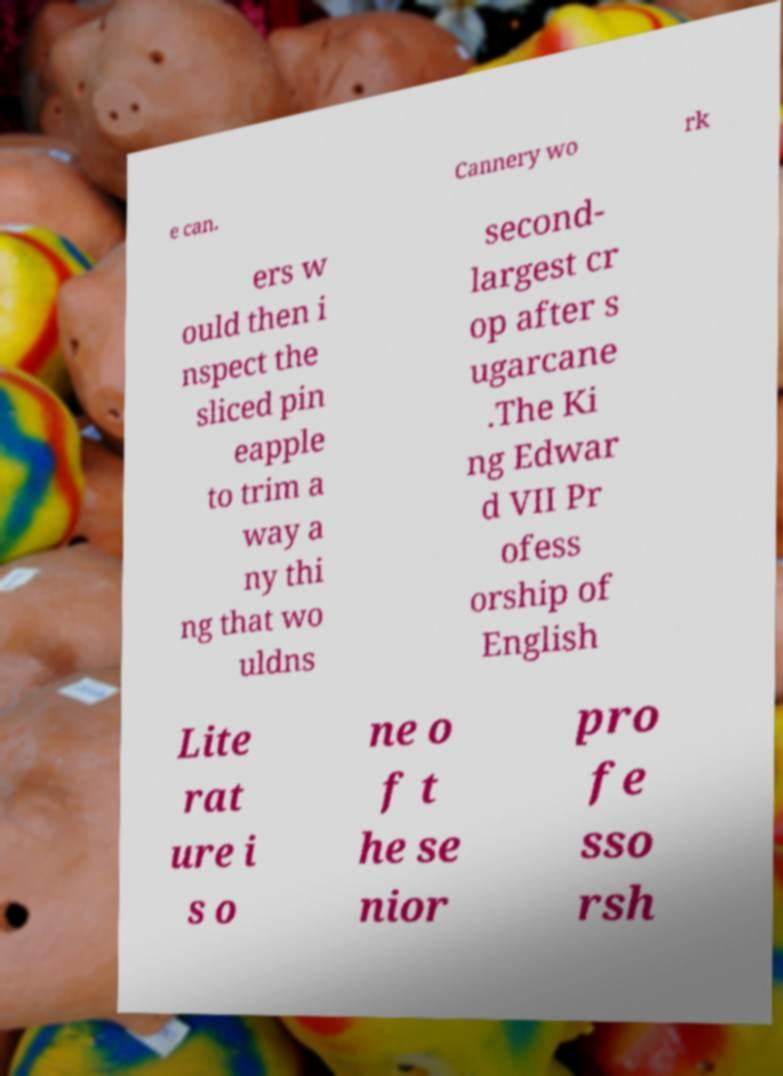Could you extract and type out the text from this image? e can. Cannery wo rk ers w ould then i nspect the sliced pin eapple to trim a way a ny thi ng that wo uldns second- largest cr op after s ugarcane .The Ki ng Edwar d VII Pr ofess orship of English Lite rat ure i s o ne o f t he se nior pro fe sso rsh 